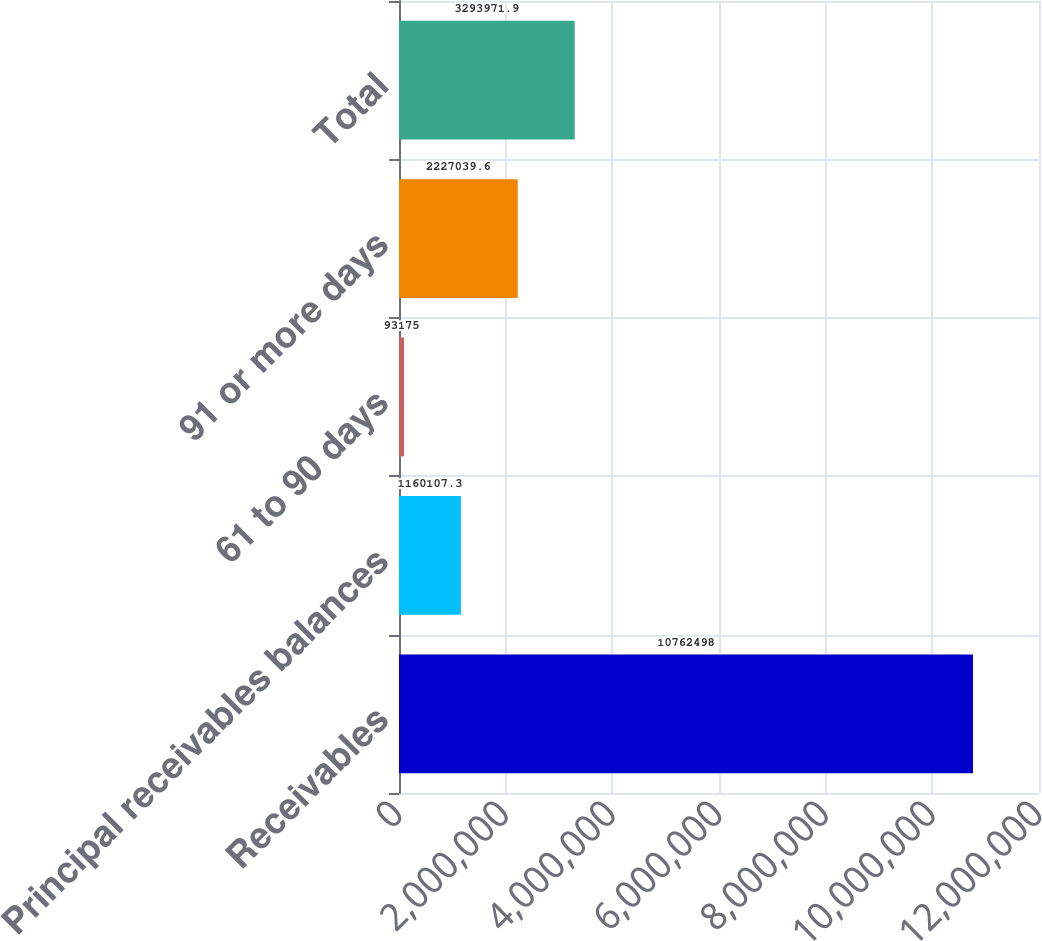Convert chart to OTSL. <chart><loc_0><loc_0><loc_500><loc_500><bar_chart><fcel>Receivables<fcel>Principal receivables balances<fcel>61 to 90 days<fcel>91 or more days<fcel>Total<nl><fcel>1.07625e+07<fcel>1.16011e+06<fcel>93175<fcel>2.22704e+06<fcel>3.29397e+06<nl></chart> 